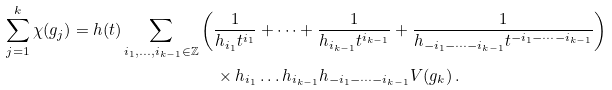Convert formula to latex. <formula><loc_0><loc_0><loc_500><loc_500>\sum _ { j = 1 } ^ { k } \chi ( g _ { j } ) = h ( t ) \sum _ { i _ { 1 } , \dots , i _ { k - 1 } \in \mathbb { Z } } & \left ( \frac { 1 } { h _ { i _ { 1 } } t ^ { i _ { 1 } } } + \dots + \frac { 1 } { h _ { i _ { k - 1 } } t ^ { i _ { k - 1 } } } + \frac { 1 } { h _ { - i _ { 1 } - \dots - i _ { k - 1 } } t ^ { - i _ { 1 } - \dots - i _ { k - 1 } } } \right ) \\ & \quad \times h _ { i _ { 1 } } \dots h _ { i _ { k - 1 } } h _ { - i _ { 1 } - \dots - i _ { k - 1 } } V ( g _ { k } ) \, .</formula> 